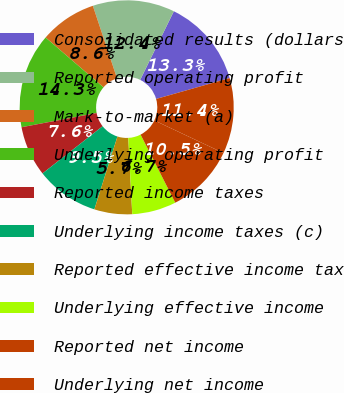Convert chart. <chart><loc_0><loc_0><loc_500><loc_500><pie_chart><fcel>Consolidated results (dollars<fcel>Reported operating profit<fcel>Mark-to-market (a)<fcel>Underlying operating profit<fcel>Reported income taxes<fcel>Underlying income taxes (c)<fcel>Reported effective income tax<fcel>Underlying effective income<fcel>Reported net income<fcel>Underlying net income<nl><fcel>13.33%<fcel>12.38%<fcel>8.57%<fcel>14.29%<fcel>7.62%<fcel>9.52%<fcel>5.71%<fcel>6.67%<fcel>10.48%<fcel>11.43%<nl></chart> 